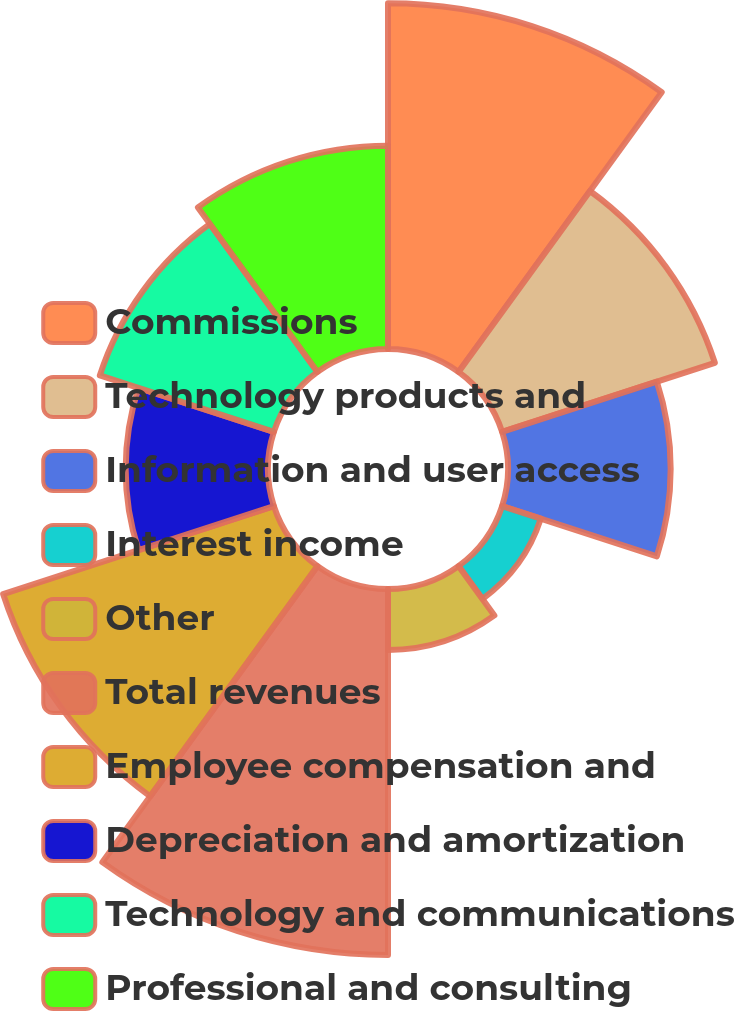Convert chart. <chart><loc_0><loc_0><loc_500><loc_500><pie_chart><fcel>Commissions<fcel>Technology products and<fcel>Information and user access<fcel>Interest income<fcel>Other<fcel>Total revenues<fcel>Employee compensation and<fcel>Depreciation and amortization<fcel>Technology and communications<fcel>Professional and consulting<nl><fcel>17.17%<fcel>11.11%<fcel>8.08%<fcel>2.02%<fcel>3.03%<fcel>18.18%<fcel>14.14%<fcel>7.07%<fcel>9.09%<fcel>10.1%<nl></chart> 